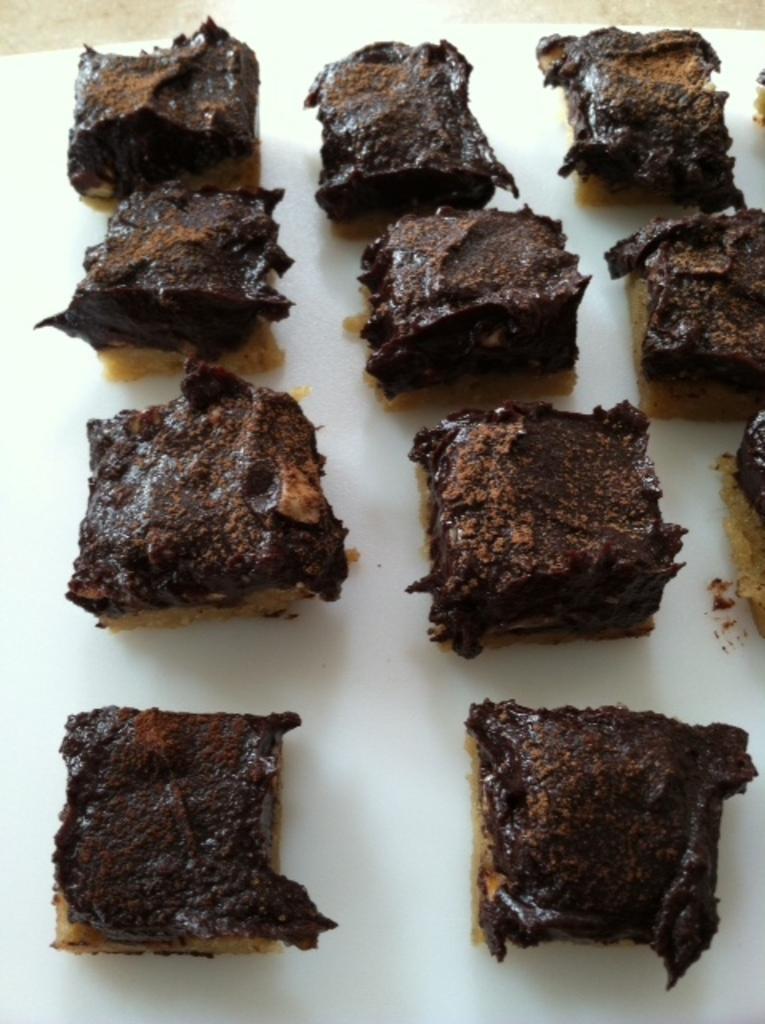How would you summarize this image in a sentence or two? In this image we can see some chocolate brownies which are on the white color surface. 